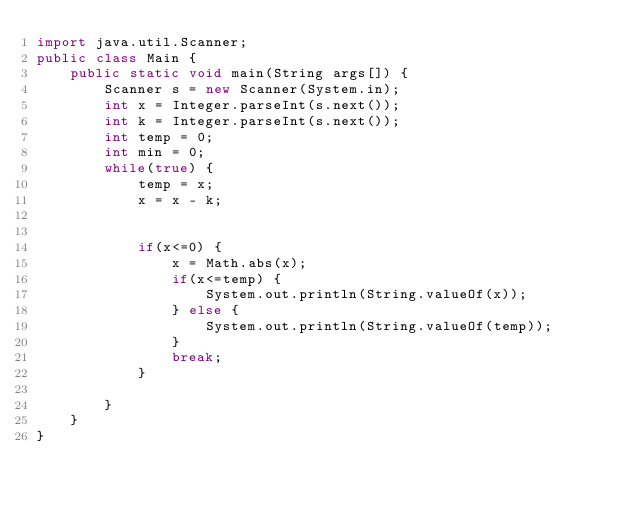Convert code to text. <code><loc_0><loc_0><loc_500><loc_500><_Java_>import java.util.Scanner;
public class Main {
    public static void main(String args[]) {
        Scanner s = new Scanner(System.in);
        int x = Integer.parseInt(s.next());
        int k = Integer.parseInt(s.next());
        int temp = 0;
        int min = 0;
        while(true) {
            temp = x;
            x = x - k;
            
            
            if(x<=0) {
                x = Math.abs(x);
                if(x<=temp) {
                    System.out.println(String.valueOf(x));
                } else {
                    System.out.println(String.valueOf(temp));
                }
                break;
            }
            
        }
    }
}</code> 